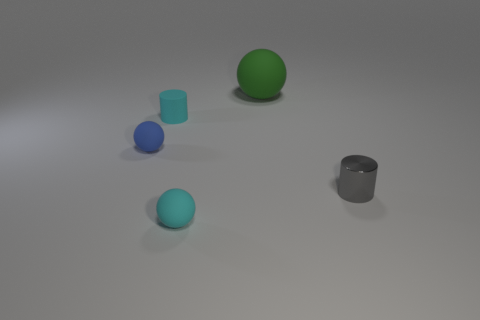Is there any other thing that is the same color as the small rubber cylinder?
Give a very brief answer. Yes. Is there anything else that is made of the same material as the small gray cylinder?
Provide a succinct answer. No. Do the tiny matte cylinder and the tiny sphere in front of the blue matte ball have the same color?
Your answer should be compact. Yes. There is a rubber object that is on the right side of the tiny cyan rubber cylinder and behind the tiny shiny object; what size is it?
Offer a very short reply. Large. There is a thing that is behind the small blue thing and in front of the green thing; what shape is it?
Provide a short and direct response. Cylinder. Are there any balls to the left of the large green thing?
Offer a terse response. Yes. What is the material of the sphere that is the same color as the rubber cylinder?
Make the answer very short. Rubber. What number of spheres are either tiny shiny things or big green objects?
Your answer should be very brief. 1. Does the green thing have the same shape as the small blue object?
Your answer should be compact. Yes. How big is the cylinder that is left of the gray cylinder?
Provide a short and direct response. Small. 